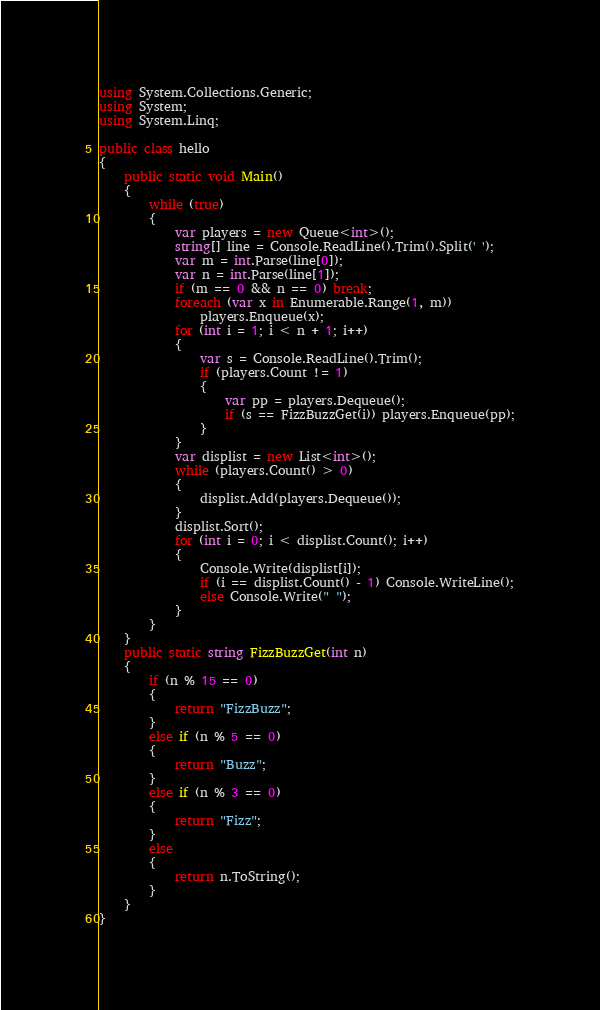<code> <loc_0><loc_0><loc_500><loc_500><_C#_>using System.Collections.Generic;
using System;
using System.Linq;

public class hello
{
    public static void Main()
    {
        while (true)
        {
            var players = new Queue<int>();
            string[] line = Console.ReadLine().Trim().Split(' ');
            var m = int.Parse(line[0]);
            var n = int.Parse(line[1]);
            if (m == 0 && n == 0) break;
            foreach (var x in Enumerable.Range(1, m))
                players.Enqueue(x);
            for (int i = 1; i < n + 1; i++)
            {
                var s = Console.ReadLine().Trim();
                if (players.Count != 1)
                {
                    var pp = players.Dequeue();
                    if (s == FizzBuzzGet(i)) players.Enqueue(pp);
                }
            }
            var displist = new List<int>();
            while (players.Count() > 0)
            {
                displist.Add(players.Dequeue());
            }
            displist.Sort();
            for (int i = 0; i < displist.Count(); i++)
            {
                Console.Write(displist[i]);
                if (i == displist.Count() - 1) Console.WriteLine();
                else Console.Write(" ");
            }
        }
    }
    public static string FizzBuzzGet(int n)
    {
        if (n % 15 == 0)
        {
            return "FizzBuzz";
        }
        else if (n % 5 == 0)
        {
            return "Buzz";
        }
        else if (n % 3 == 0)
        {
            return "Fizz";
        }
        else
        {
            return n.ToString();
        }
    }
}</code> 